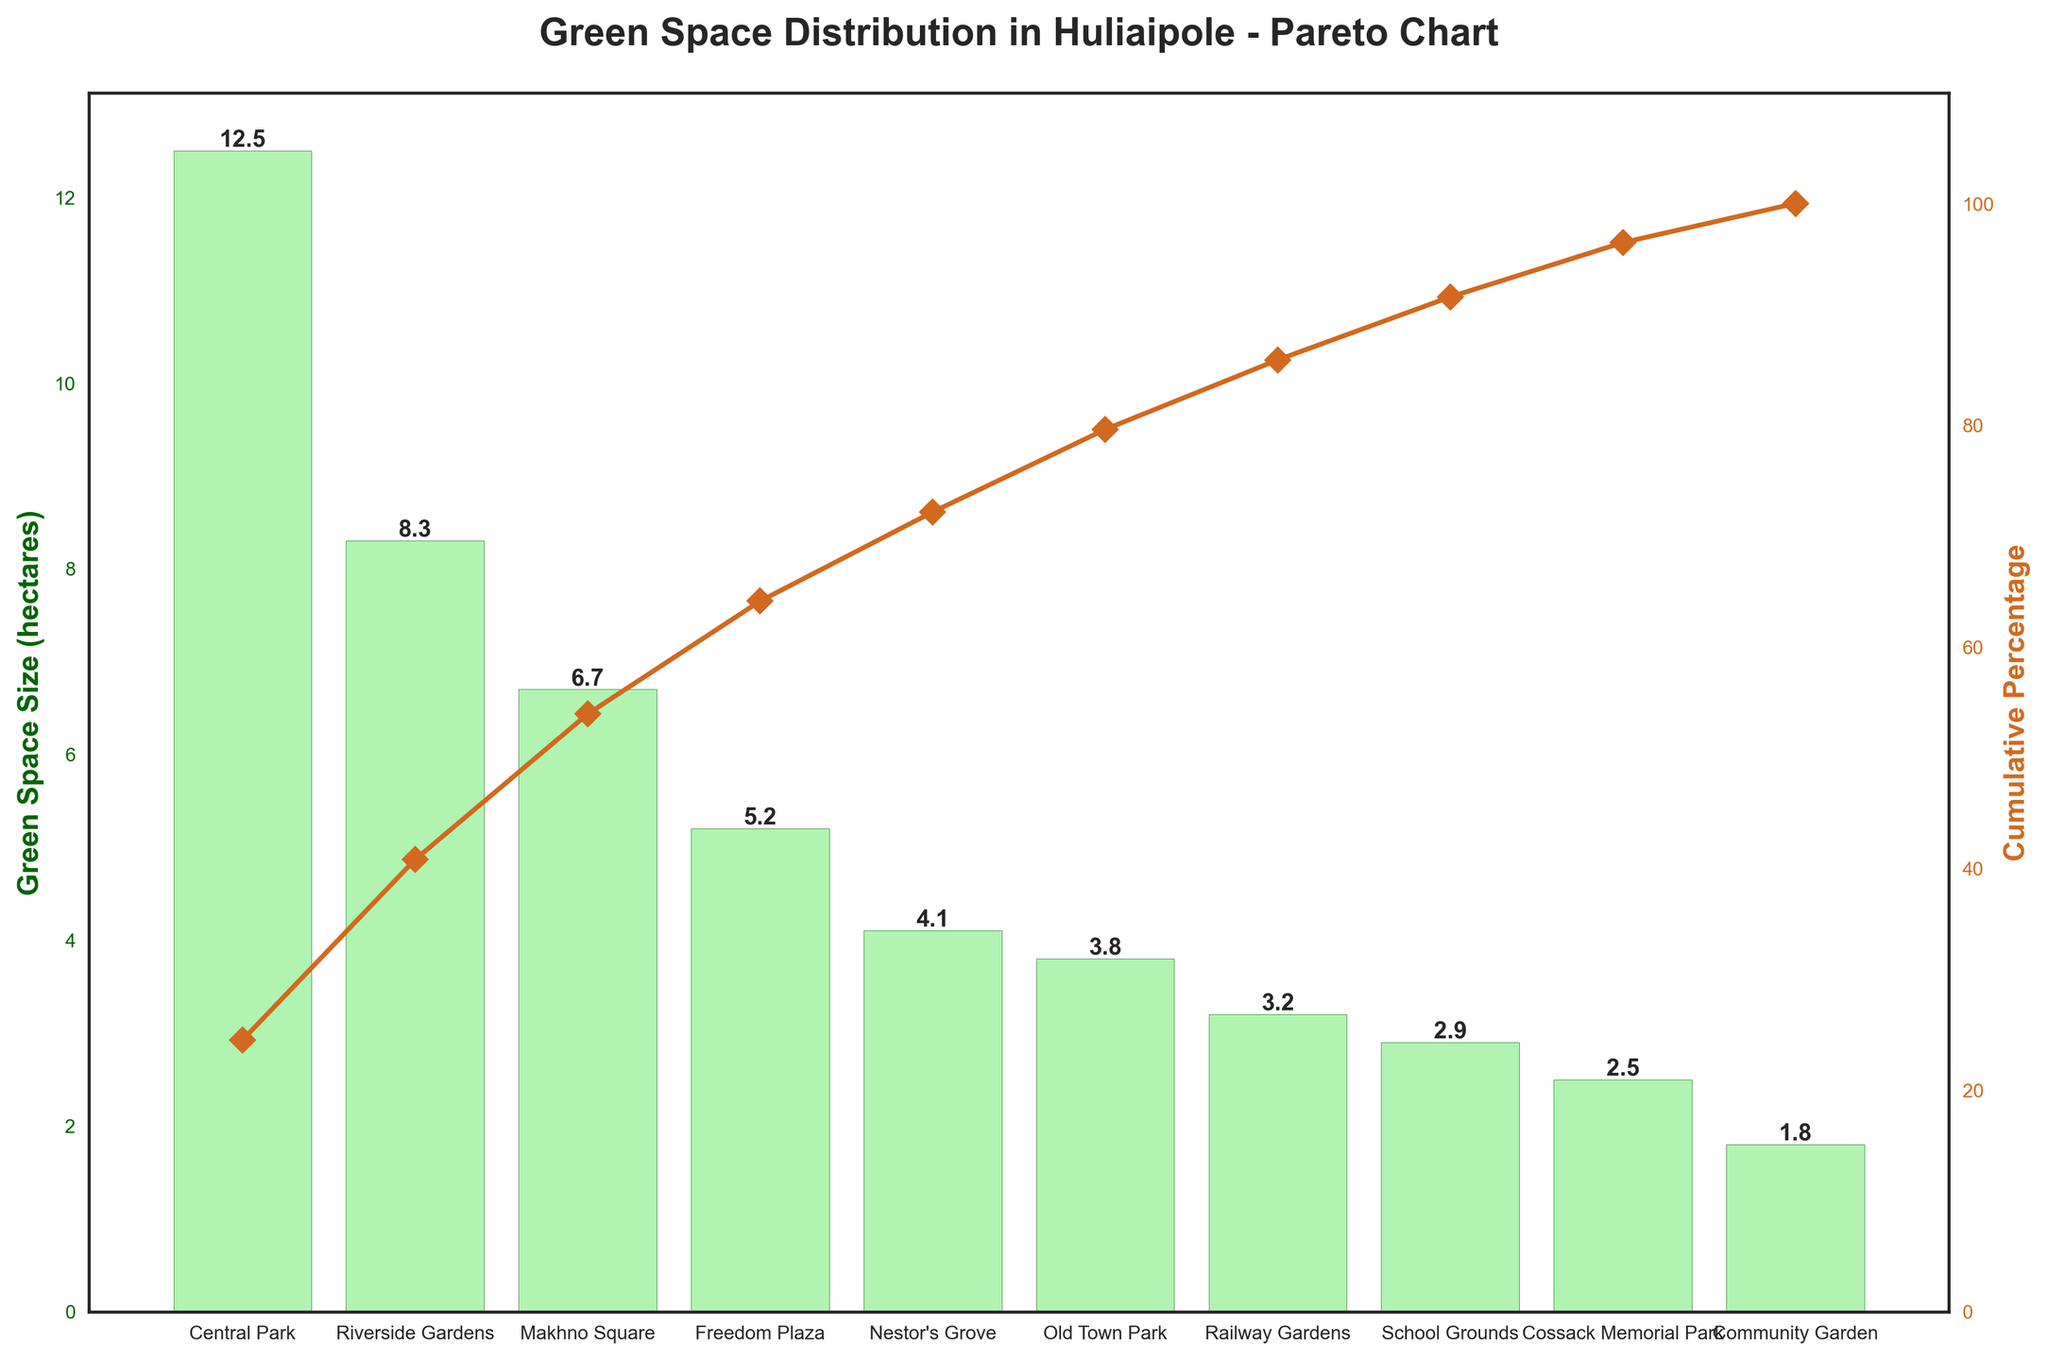what is the title of the chart? The title of the chart is located at the top, written in a large and bold font. It summarizes the content and focus of the chart.
Answer: Green Space Distribution in Huliaipole - Pareto Chart How many green spaces are represented in the chart? To determine the number of green spaces, count all the distinct areas listed along the x-axis.
Answer: 10 What color are the bars representing the green space size? The bars representing green space size are colored in a particular way for visual clarity. They appear light but outlined in a distinct color.
Answer: Light green with dark green edges What is the green space with the largest area? Examine the heights of the bars along the x-axis and identify the tallest one to determine the green space with the largest area.
Answer: Central Park Which green space is responsible for approximately half (50%) of the cumulative percentage? Look at the cumulative percentage line and figure out which green space crosses the 50% mark on the secondary y-axis.
Answer: Riverside Gardens What is the difference in size between the largest and smallest green spaces? Subtract the area size of the green space with the smallest bar from that of the one with the tallest bar. Central Park is 12.5 hectares, and Community Garden is 1.8 hectares.
Answer: 10.7 hectares Which three green spaces contribute to approximately 65% of the total area? Follow the cumulative percentage line to the point closest to 65% and note the green spaces up to that point.
Answer: Central Park, Riverside Gardens, and Makhno Square What's the cumulative percentage up to Old Town Park? Check the cumulative percentage line plotted against Old Town Park on the x-axis and note the value on the secondary y-axis.
Answer: 80% What's the sum of the green space sizes for the smallest three parks? Add the sizes of the three green spaces with the smallest bars (Cossack Memorial Park, School Grounds, and Community Garden) for the total.
Answer: 7.2 hectares What green spaces together make up more than 90% of the total green space area? Observe the cumulative percentage line and identify the set of green spaces after which the cumulative percentage surpasses 90%.
Answer: Central Park, Riverside Gardens, Makhno Square, Freedom Plaza, Nestor's Grove, and Old Town Park 